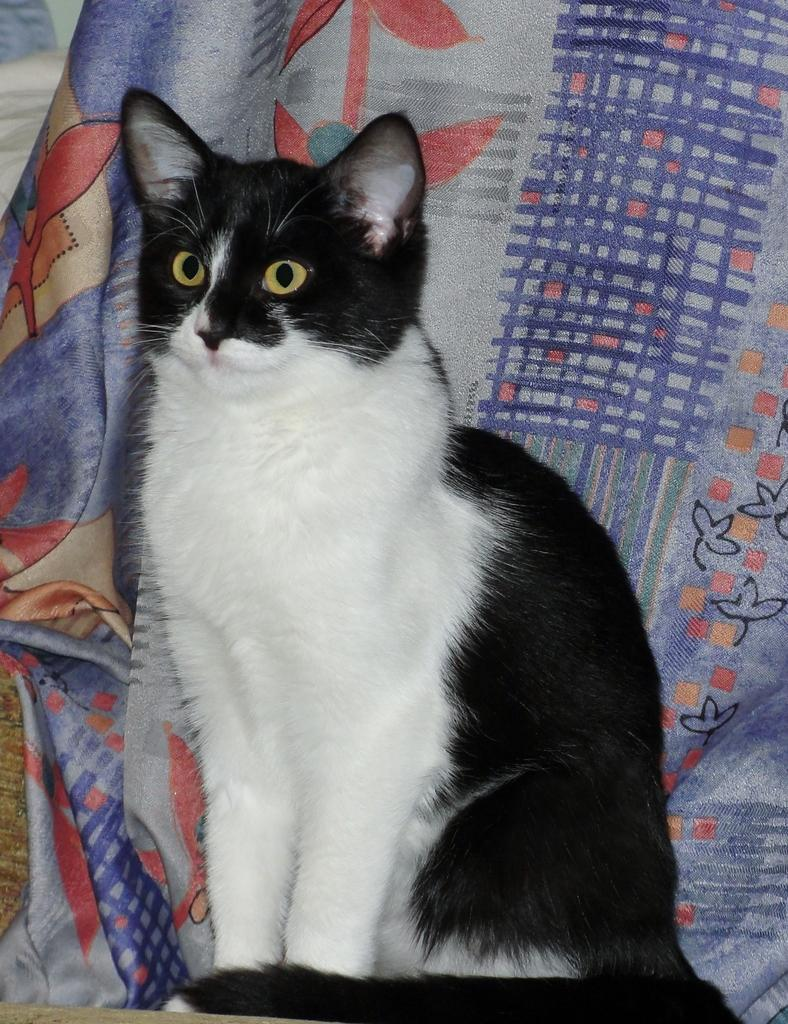What animal is the main subject of the image? There is a cat in the image. What colors can be seen on the cat? The cat is black and white in color. Where is the cat located in the image? The cat is in the middle of the image. What can be seen in the background of the image? There is a cloth in the background of the image. What type of stitch is the cat using to sew the farmer's yoke in the image? There is no stitch, farmer, or yoke present in the image; it features a black and white cat in the middle of the image. 